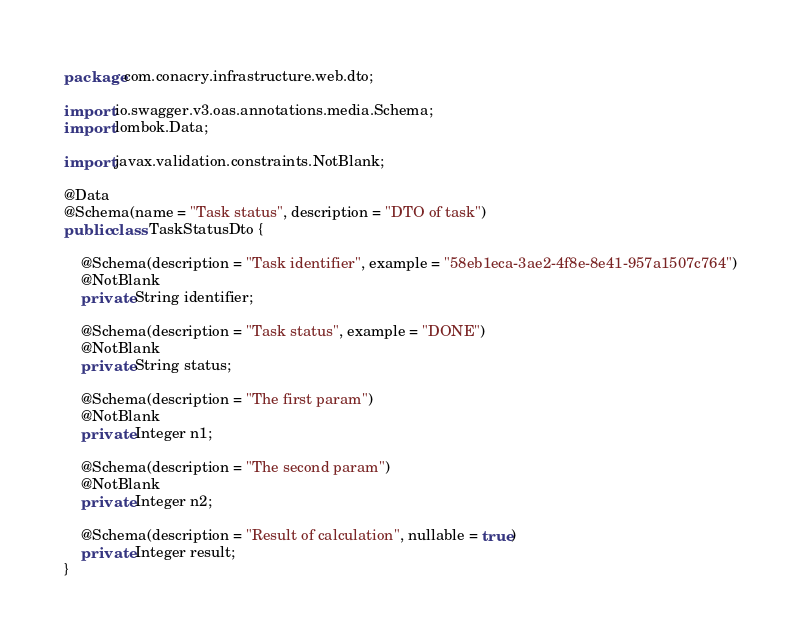<code> <loc_0><loc_0><loc_500><loc_500><_Java_>package com.conacry.infrastructure.web.dto;

import io.swagger.v3.oas.annotations.media.Schema;
import lombok.Data;

import javax.validation.constraints.NotBlank;

@Data
@Schema(name = "Task status", description = "DTO of task")
public class TaskStatusDto {

    @Schema(description = "Task identifier", example = "58eb1eca-3ae2-4f8e-8e41-957a1507c764")
    @NotBlank
    private String identifier;

    @Schema(description = "Task status", example = "DONE")
    @NotBlank
    private String status;

    @Schema(description = "The first param")
    @NotBlank
    private Integer n1;

    @Schema(description = "The second param")
    @NotBlank
    private Integer n2;

    @Schema(description = "Result of calculation", nullable = true)
    private Integer result;
}
</code> 